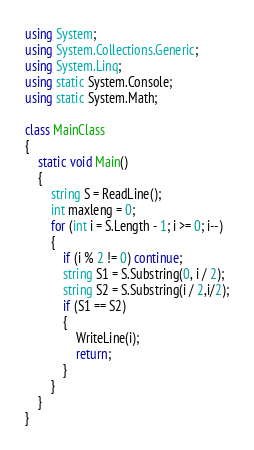<code> <loc_0><loc_0><loc_500><loc_500><_C#_>using System;
using System.Collections.Generic;
using System.Linq;
using static System.Console;
using static System.Math;

class MainClass
{
    static void Main()
    {
        string S = ReadLine();
        int maxleng = 0;
        for (int i = S.Length - 1; i >= 0; i--)
        {
            if (i % 2 != 0) continue;
            string S1 = S.Substring(0, i / 2);
            string S2 = S.Substring(i / 2,i/2);
            if (S1 == S2)
            {
                WriteLine(i);
                return;
            }
        }
    }
}
</code> 